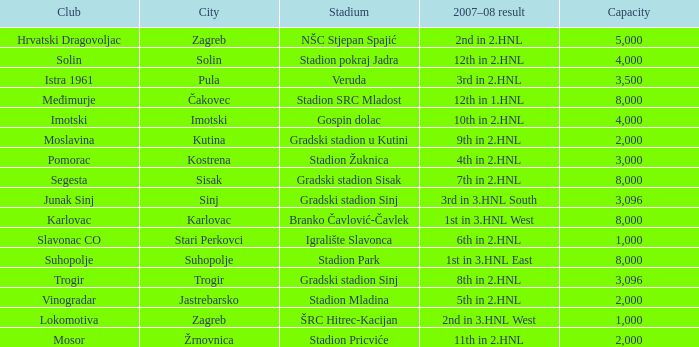What stadium has 9th in 2.hnl as the 2007-08 result? Gradski stadion u Kutini. 